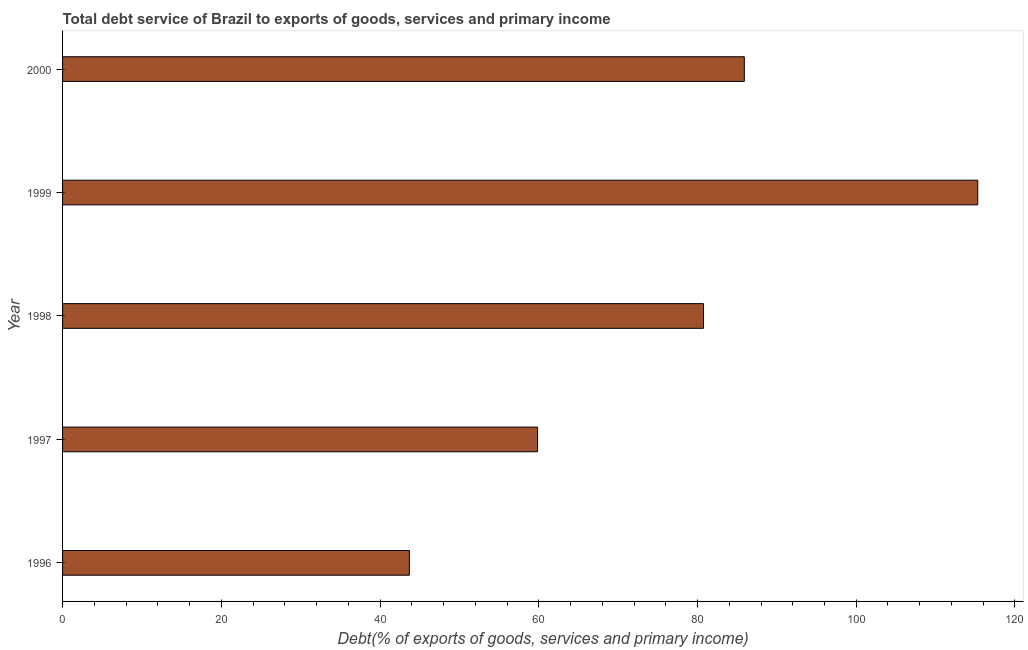Does the graph contain any zero values?
Offer a terse response. No. Does the graph contain grids?
Your response must be concise. No. What is the title of the graph?
Your answer should be compact. Total debt service of Brazil to exports of goods, services and primary income. What is the label or title of the X-axis?
Your answer should be very brief. Debt(% of exports of goods, services and primary income). What is the label or title of the Y-axis?
Your answer should be very brief. Year. What is the total debt service in 1997?
Ensure brevity in your answer.  59.85. Across all years, what is the maximum total debt service?
Your response must be concise. 115.31. Across all years, what is the minimum total debt service?
Offer a very short reply. 43.69. In which year was the total debt service maximum?
Offer a terse response. 1999. What is the sum of the total debt service?
Keep it short and to the point. 385.5. What is the difference between the total debt service in 1996 and 1999?
Your answer should be very brief. -71.61. What is the average total debt service per year?
Give a very brief answer. 77.1. What is the median total debt service?
Your answer should be very brief. 80.76. In how many years, is the total debt service greater than 104 %?
Ensure brevity in your answer.  1. Is the total debt service in 1996 less than that in 2000?
Make the answer very short. Yes. Is the difference between the total debt service in 1996 and 2000 greater than the difference between any two years?
Your answer should be compact. No. What is the difference between the highest and the second highest total debt service?
Your answer should be compact. 29.41. What is the difference between the highest and the lowest total debt service?
Your answer should be very brief. 71.61. In how many years, is the total debt service greater than the average total debt service taken over all years?
Ensure brevity in your answer.  3. How many bars are there?
Your answer should be very brief. 5. Are all the bars in the graph horizontal?
Your response must be concise. Yes. How many years are there in the graph?
Your answer should be compact. 5. Are the values on the major ticks of X-axis written in scientific E-notation?
Ensure brevity in your answer.  No. What is the Debt(% of exports of goods, services and primary income) of 1996?
Offer a terse response. 43.69. What is the Debt(% of exports of goods, services and primary income) of 1997?
Keep it short and to the point. 59.85. What is the Debt(% of exports of goods, services and primary income) of 1998?
Provide a succinct answer. 80.76. What is the Debt(% of exports of goods, services and primary income) of 1999?
Your response must be concise. 115.31. What is the Debt(% of exports of goods, services and primary income) of 2000?
Your answer should be compact. 85.9. What is the difference between the Debt(% of exports of goods, services and primary income) in 1996 and 1997?
Make the answer very short. -16.15. What is the difference between the Debt(% of exports of goods, services and primary income) in 1996 and 1998?
Provide a succinct answer. -37.06. What is the difference between the Debt(% of exports of goods, services and primary income) in 1996 and 1999?
Make the answer very short. -71.61. What is the difference between the Debt(% of exports of goods, services and primary income) in 1996 and 2000?
Your answer should be compact. -42.2. What is the difference between the Debt(% of exports of goods, services and primary income) in 1997 and 1998?
Provide a short and direct response. -20.91. What is the difference between the Debt(% of exports of goods, services and primary income) in 1997 and 1999?
Offer a very short reply. -55.46. What is the difference between the Debt(% of exports of goods, services and primary income) in 1997 and 2000?
Give a very brief answer. -26.05. What is the difference between the Debt(% of exports of goods, services and primary income) in 1998 and 1999?
Give a very brief answer. -34.55. What is the difference between the Debt(% of exports of goods, services and primary income) in 1998 and 2000?
Your answer should be compact. -5.14. What is the difference between the Debt(% of exports of goods, services and primary income) in 1999 and 2000?
Make the answer very short. 29.41. What is the ratio of the Debt(% of exports of goods, services and primary income) in 1996 to that in 1997?
Make the answer very short. 0.73. What is the ratio of the Debt(% of exports of goods, services and primary income) in 1996 to that in 1998?
Your response must be concise. 0.54. What is the ratio of the Debt(% of exports of goods, services and primary income) in 1996 to that in 1999?
Offer a terse response. 0.38. What is the ratio of the Debt(% of exports of goods, services and primary income) in 1996 to that in 2000?
Offer a terse response. 0.51. What is the ratio of the Debt(% of exports of goods, services and primary income) in 1997 to that in 1998?
Your answer should be very brief. 0.74. What is the ratio of the Debt(% of exports of goods, services and primary income) in 1997 to that in 1999?
Your answer should be very brief. 0.52. What is the ratio of the Debt(% of exports of goods, services and primary income) in 1997 to that in 2000?
Ensure brevity in your answer.  0.7. What is the ratio of the Debt(% of exports of goods, services and primary income) in 1998 to that in 1999?
Your answer should be compact. 0.7. What is the ratio of the Debt(% of exports of goods, services and primary income) in 1999 to that in 2000?
Keep it short and to the point. 1.34. 